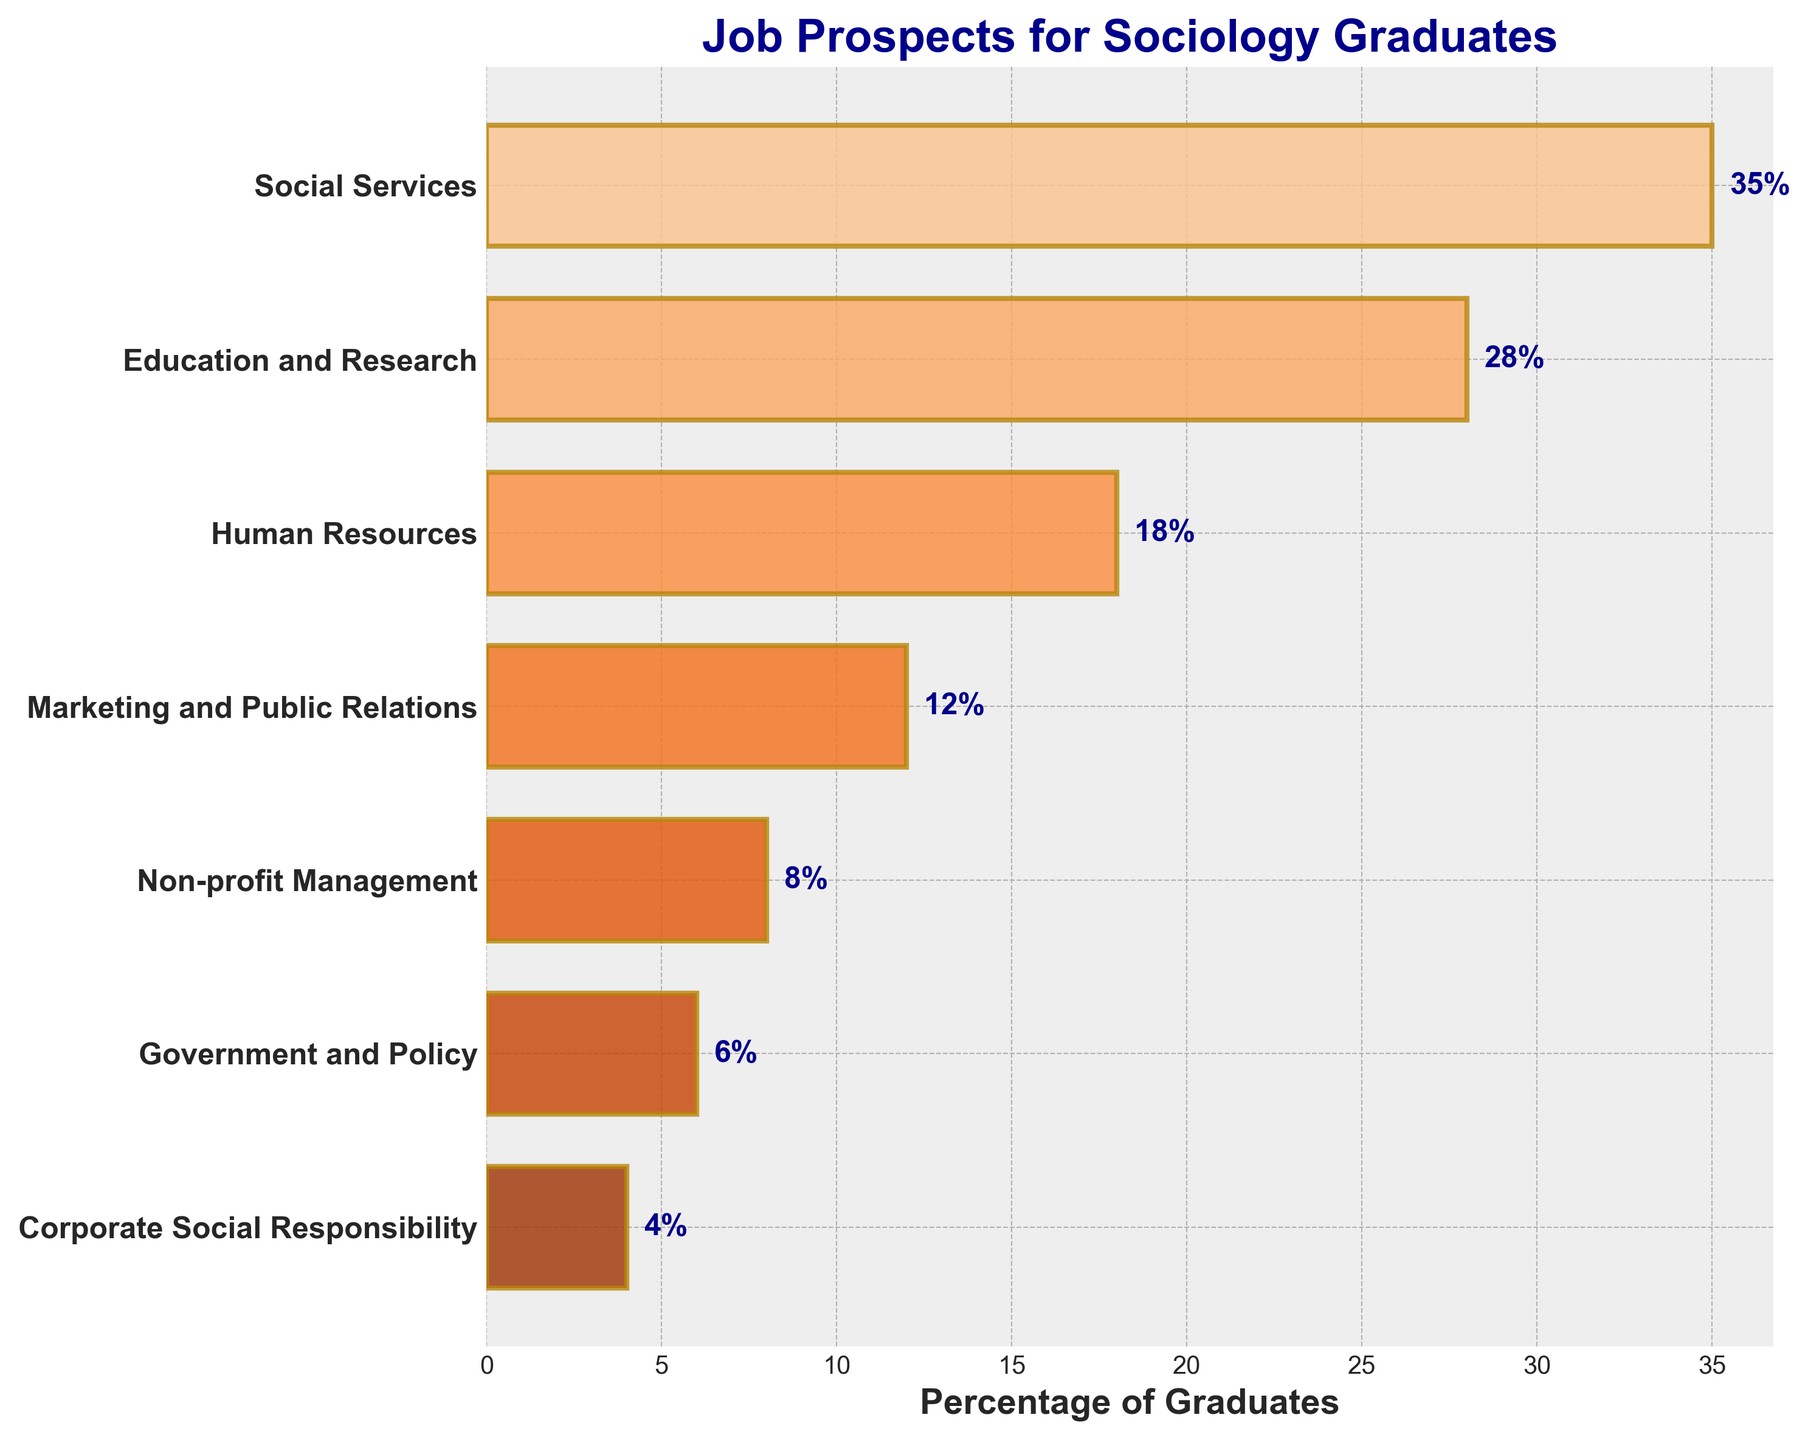What is the title of the figure? The title is located at the top of the figure, and it usually is in a larger and bold font for easy visibility. It's designed to encapsulate the overall content of the chart.
Answer: Job Prospects for Sociology Graduates Which career path has the highest percentage of graduates? The highest percentage can be identified by the longest bar in the horizontal bar chart. This bar is at the top because the categories are usually listed from the highest to the lowest.
Answer: Social Services How many career paths have a percentage of graduates less than 10%? To solve this, we need to count the number of bars whose length corresponds to percentages below 10%. According to the chart data, Non-profit Management, Government and Policy, and Corporate Social Responsibility fit this criterion.
Answer: 3 What is the sum of the percentages for Marketing and Public Relations, and Education and Research? By looking at the lengths of the bars corresponding to these two categories, we can add their percentages together (12% + 28%).
Answer: 40% Which career paths have a higher percentage of graduates than Human Resources? Compare the percentages of different career paths with that of Human Resources (18%). Those that exceed 18% are Social Services and Education and Research.
Answer: Social Services, Education and Research What is the percentage difference between the top career path and the lowest one? Find the percentages of the top (Social Services, 35%) and the bottom (Corporate Social Responsibility, 4%) career paths and subtract the latter from the former.
Answer: 31% Which career path has the closest percentage to the average percentage across all career paths? To find the average, sum all percentages (35+28+18+12+8+6+4 = 111) and divide by the number of career paths (7), which gives approximately 15.86%. Compare this average to each career path's percentage and find the closest value, which is Human Resources (18%).
Answer: Human Resources How does the length of the bar for Education and Research compare to that of Marketing and Public Relations? By looking at the chart, you can see that the bar length for Education and Research is significantly longer than that for Marketing and Public Relations.
Answer: The bar for Education and Research is longer What percentage of the total graduates are in non-profit management and government and policy combined? Add the percentages of Non-profit Management (8%) and Government and Policy (6%). Together, they make up a total of 14%.
Answer: 14% What is the visual technique used to show the percentages on the bars? The numbers are shown next to each bar to clearly indicate the exact percentage, and these numbers are placed at the end of each corresponding bar for easy reading.
Answer: Numbers placed at the end of each bar 